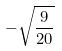Convert formula to latex. <formula><loc_0><loc_0><loc_500><loc_500>- \sqrt { \frac { 9 } { 2 0 } }</formula> 